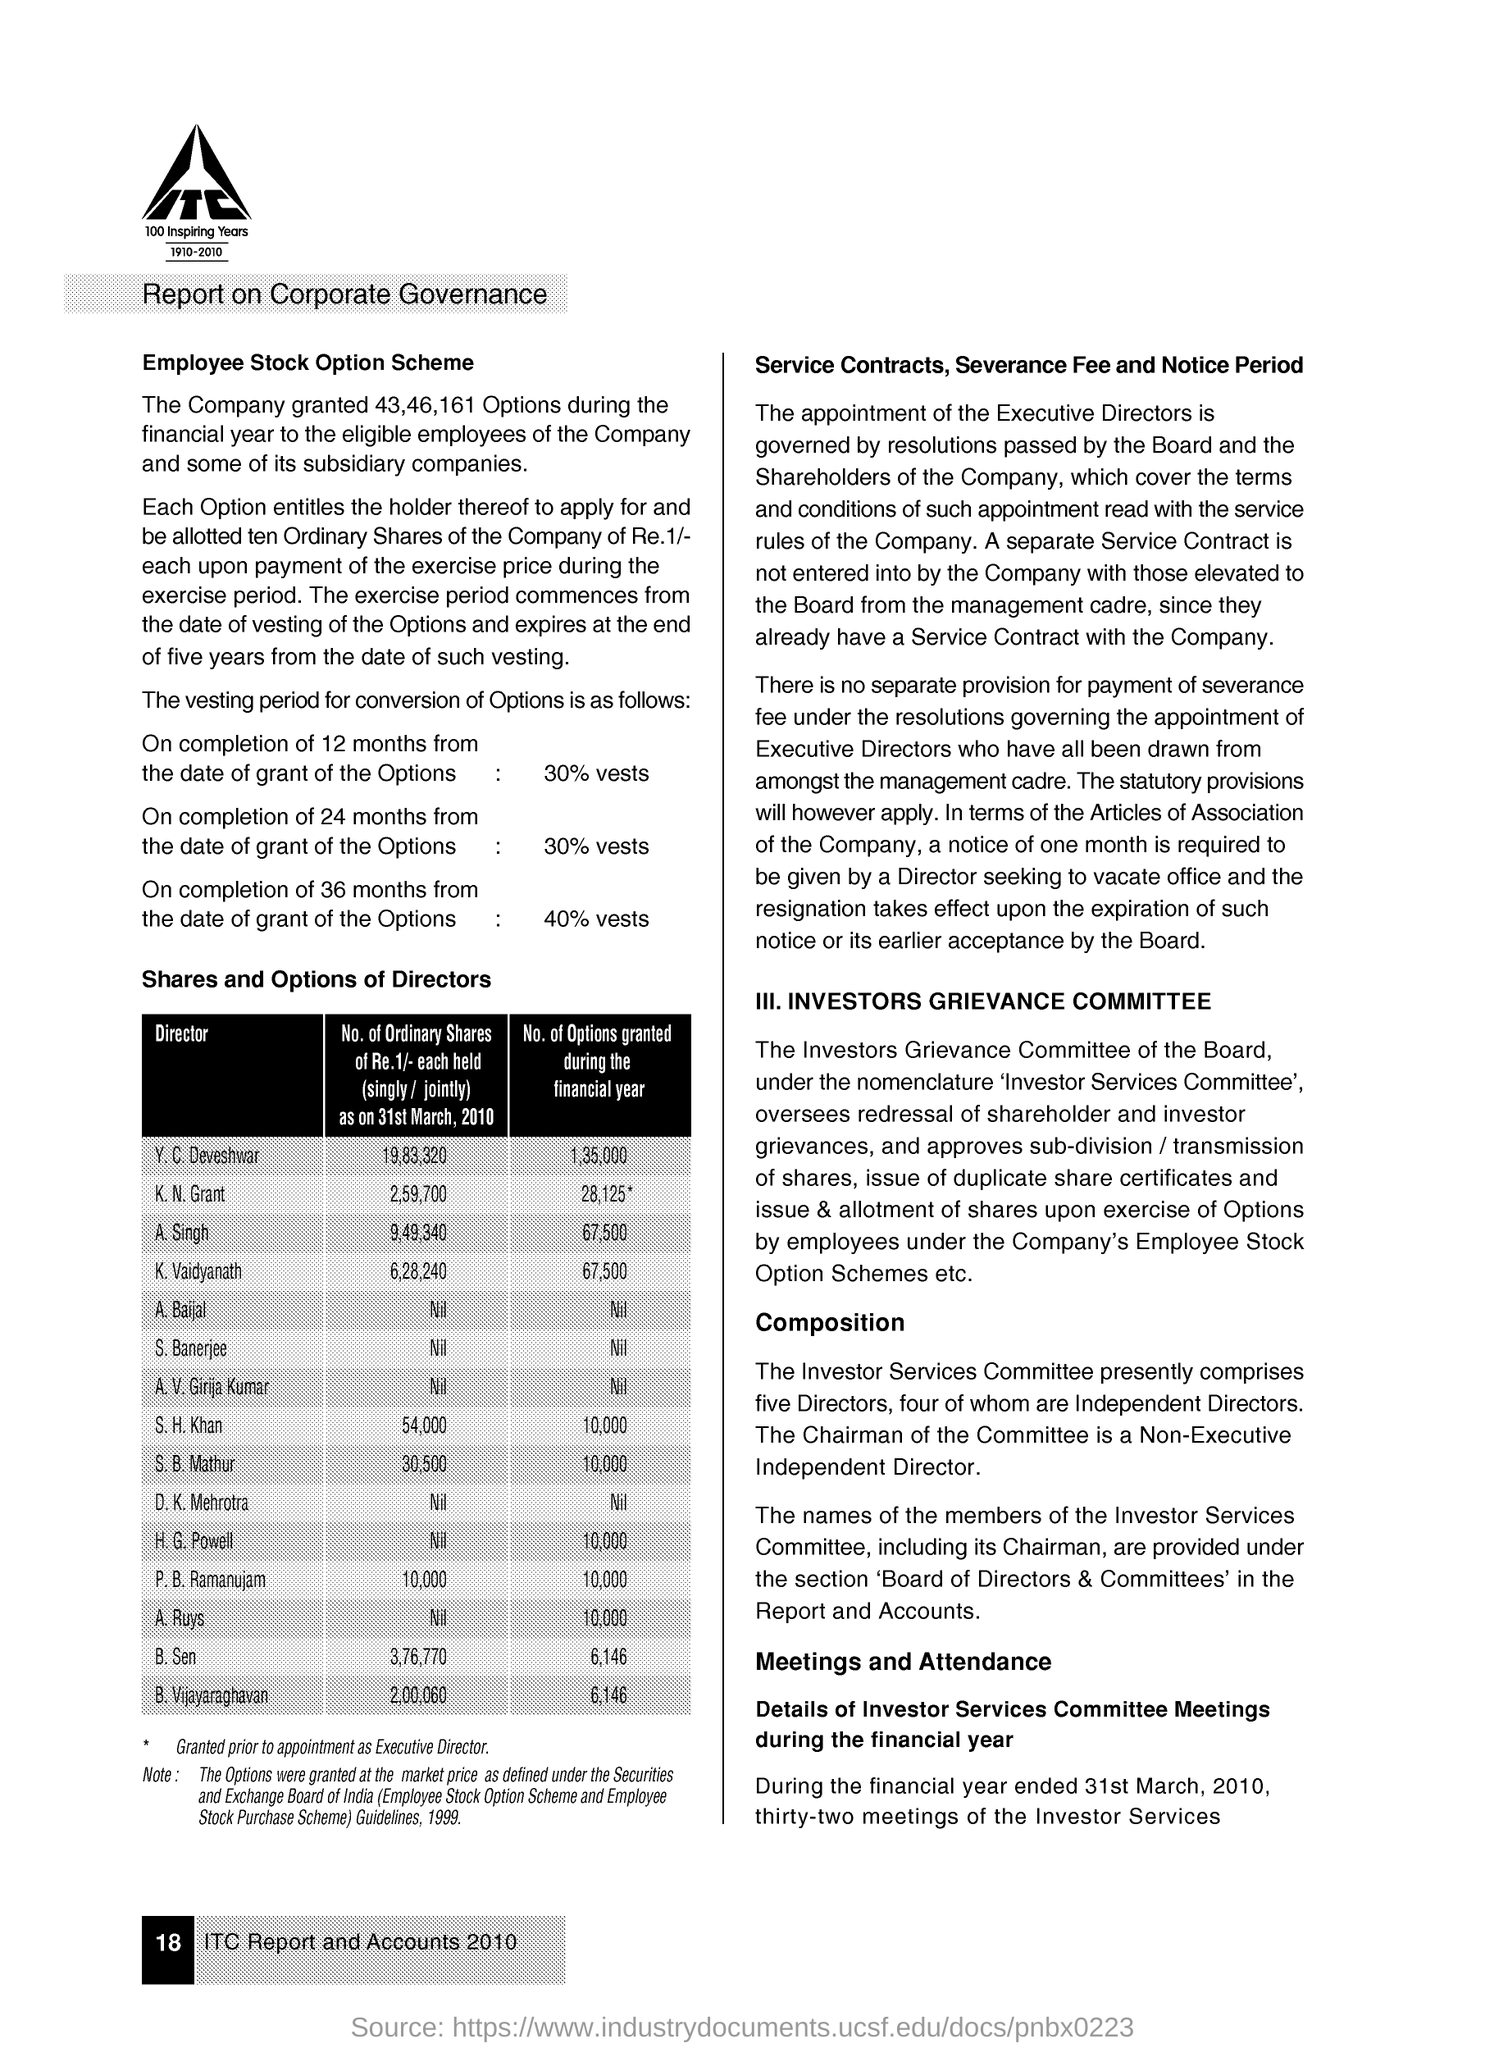Specify some key components in this picture. The page number mentioned in this document is 18. Forty percent of the options will vest over a period of 36 months from the date of grant. The number of options granted during the financial year to Y. C. Deveshwar was 1,35,000. Thirty percent of the options will vest over a period of 12 months from the date of grant of the options. The number of options granted to B. Sen during the financial year was 6,146. 